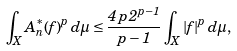Convert formula to latex. <formula><loc_0><loc_0><loc_500><loc_500>\int _ { X } A _ { n } ^ { * } ( f ) ^ { p } \, d \mu \leq \frac { 4 \, p \, 2 ^ { p - 1 } } { p - 1 } \int _ { X } | f | ^ { p } \, d \mu ,</formula> 